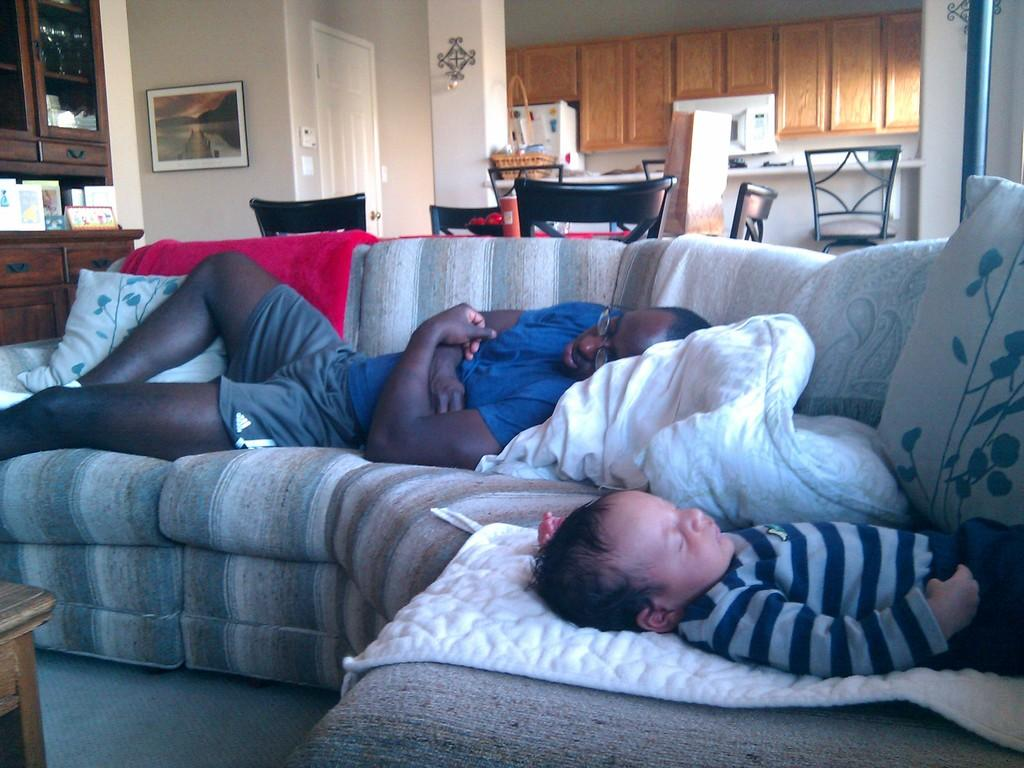What are the two persons in the image doing? The two persons are sleeping on the sofa. What furniture is located behind the sofa? There are chairs behind the sofa. What can be found on the left side of the image? There are cupboards, a photo frame, and a white door on the left side of the image. What type of zipper can be seen on the sofa in the image? There is no zipper present on the sofa in the image. Is there a slope visible in the image? There is no slope visible in the image; it appears to be a flat, indoor setting. 